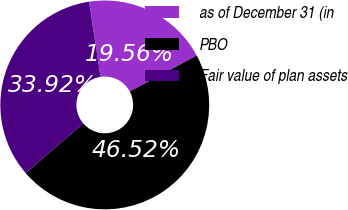Convert chart. <chart><loc_0><loc_0><loc_500><loc_500><pie_chart><fcel>as of December 31 (in<fcel>PBO<fcel>Fair value of plan assets<nl><fcel>19.56%<fcel>46.52%<fcel>33.92%<nl></chart> 